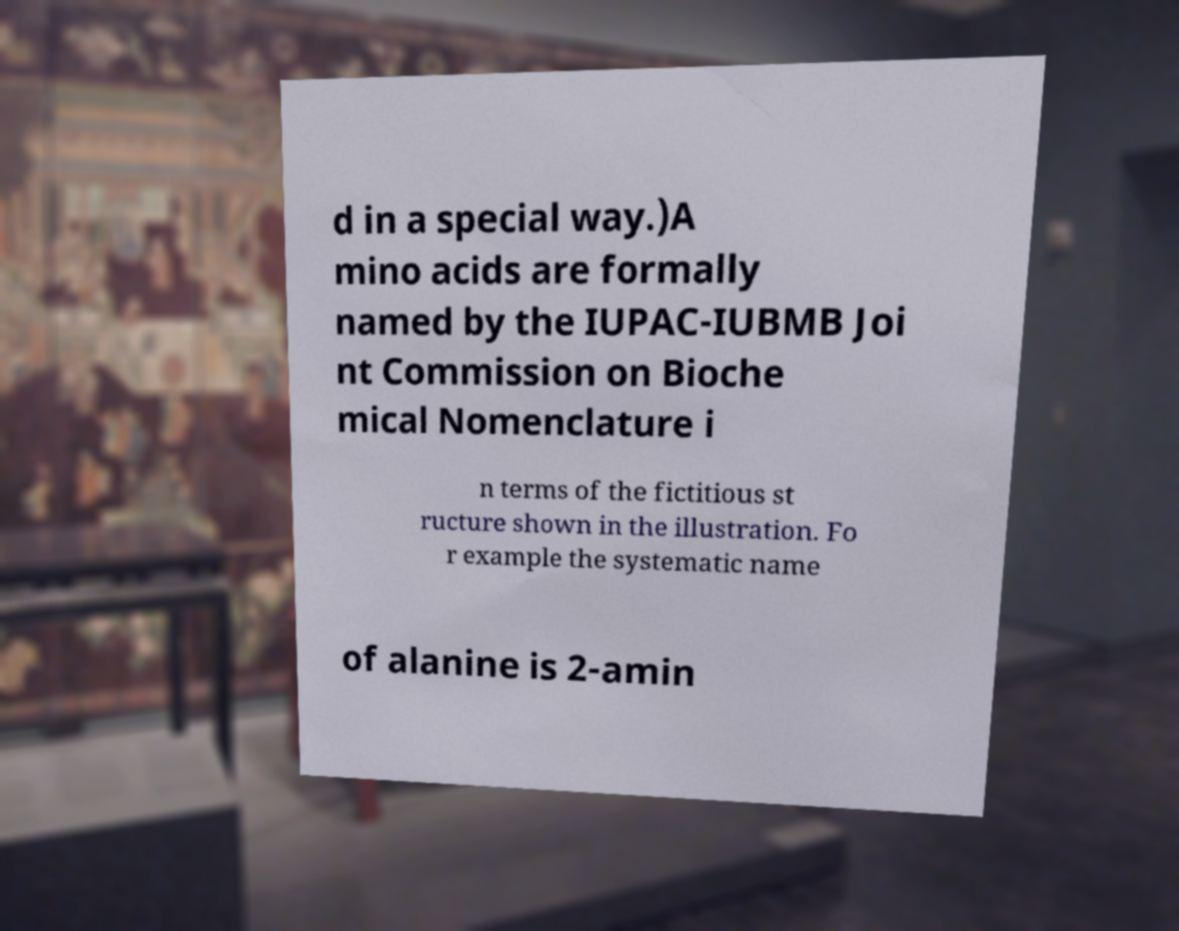I need the written content from this picture converted into text. Can you do that? d in a special way.)A mino acids are formally named by the IUPAC-IUBMB Joi nt Commission on Bioche mical Nomenclature i n terms of the fictitious st ructure shown in the illustration. Fo r example the systematic name of alanine is 2-amin 